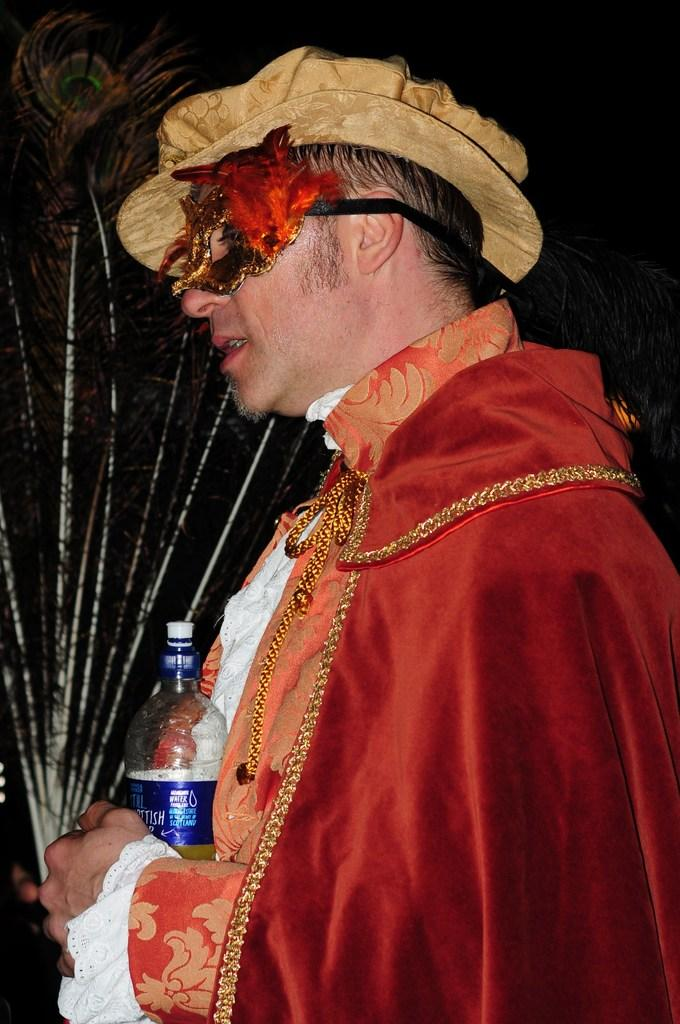What is present in the image? There is a person in the image. Can you describe the person's attire? The person is wearing clothes and a hat. What objects is the person holding? The person is holding a bottle and peacock feathers. Are there any police officers or passengers visible in the image? No, there are no police officers or passengers present in the image. Is there a harbor or any boats visible in the image? No, there is no harbor or boats present in the image. 